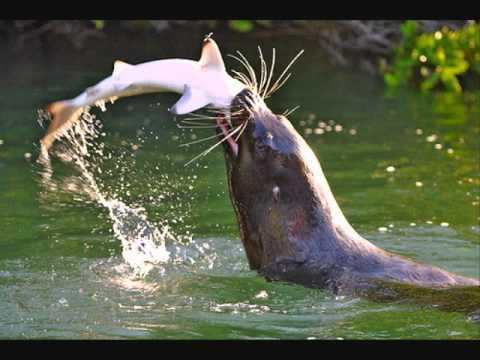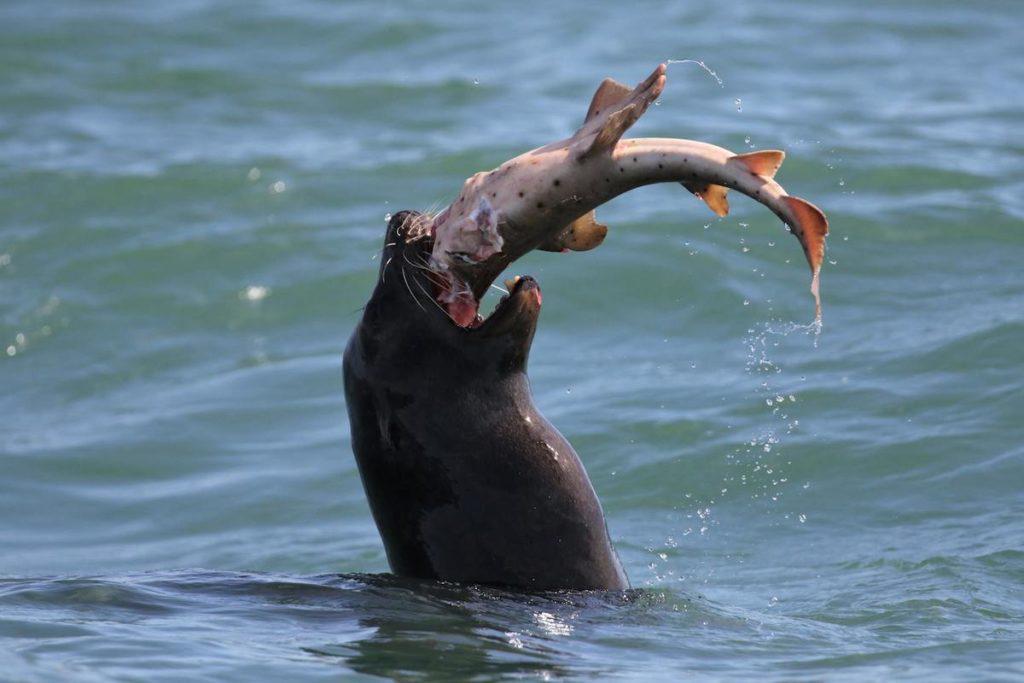The first image is the image on the left, the second image is the image on the right. Considering the images on both sides, is "All of the images contains only animals and water and nothing else." valid? Answer yes or no. No. The first image is the image on the left, the second image is the image on the right. Evaluate the accuracy of this statement regarding the images: "The seal in the left image is facing left with food in its mouth.". Is it true? Answer yes or no. Yes. 